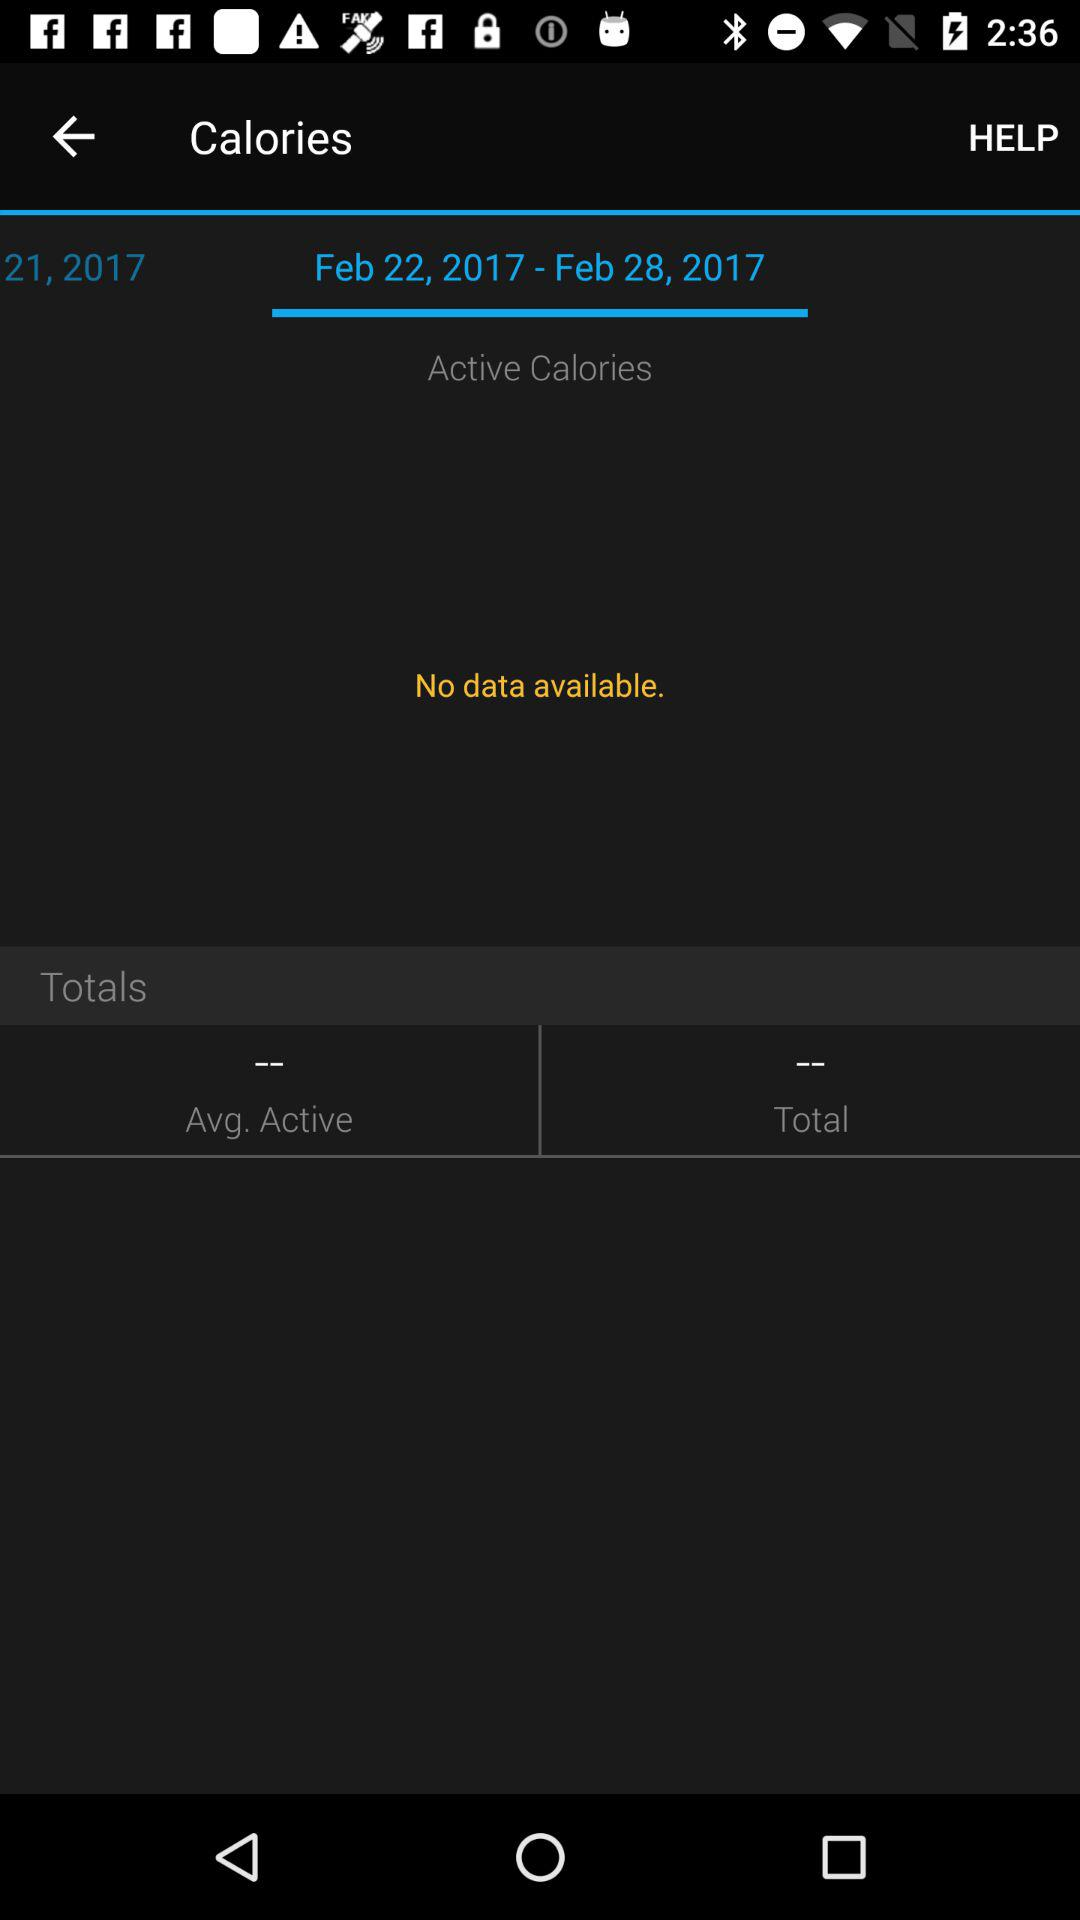How do we contact for help?
When the provided information is insufficient, respond with <no answer>. <no answer> 